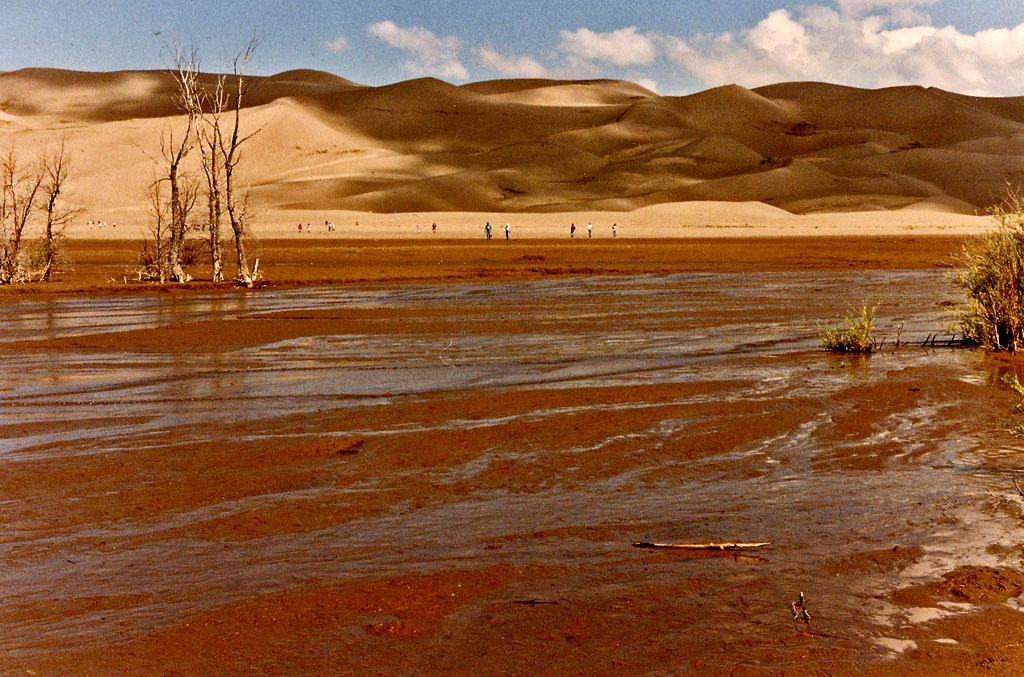What is the main feature of the image? The main feature of the image is water. What other natural elements can be seen in the image? There are trees, mountains, and the sky visible in the image. Are there any people present in the image? Yes, there are people standing in the image. What is the condition of the sky in the image? The sky is visible in the background of the image, and clouds are present. What type of sugar is being used by the dad in the image? There is no dad present in the image, and therefore no sugar or related activity can be observed. 